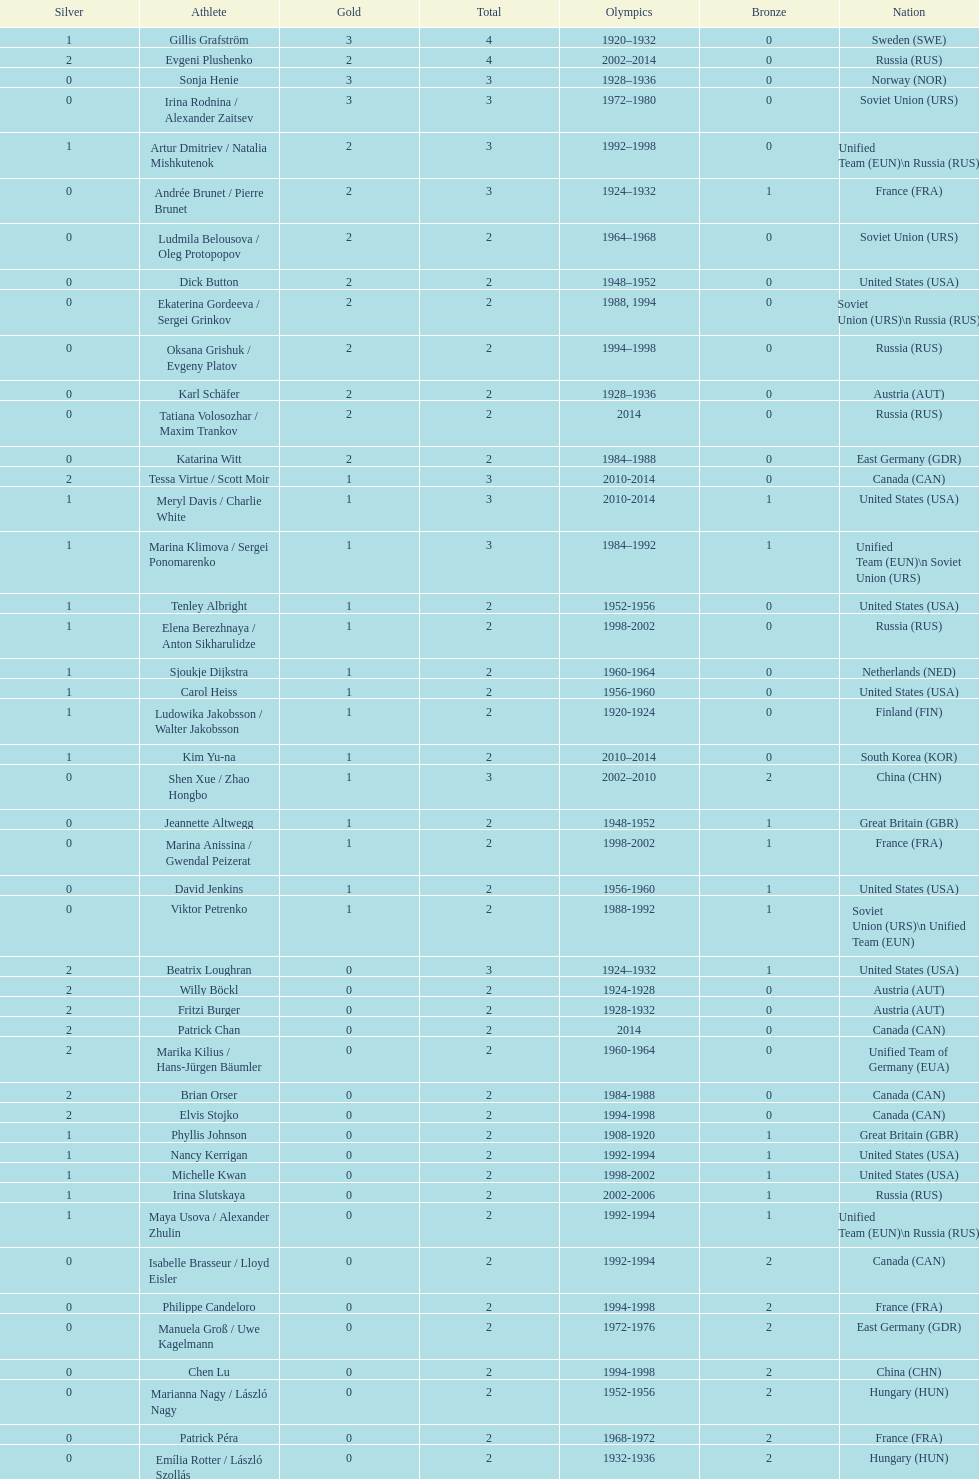How many more silver medals did gillis grafström have compared to sonja henie? 1. Could you parse the entire table as a dict? {'header': ['Silver', 'Athlete', 'Gold', 'Total', 'Olympics', 'Bronze', 'Nation'], 'rows': [['1', 'Gillis Grafström', '3', '4', '1920–1932', '0', 'Sweden\xa0(SWE)'], ['2', 'Evgeni Plushenko', '2', '4', '2002–2014', '0', 'Russia\xa0(RUS)'], ['0', 'Sonja Henie', '3', '3', '1928–1936', '0', 'Norway\xa0(NOR)'], ['0', 'Irina Rodnina / Alexander Zaitsev', '3', '3', '1972–1980', '0', 'Soviet Union\xa0(URS)'], ['1', 'Artur Dmitriev / Natalia Mishkutenok', '2', '3', '1992–1998', '0', 'Unified Team\xa0(EUN)\\n\xa0Russia\xa0(RUS)'], ['0', 'Andrée Brunet / Pierre Brunet', '2', '3', '1924–1932', '1', 'France\xa0(FRA)'], ['0', 'Ludmila Belousova / Oleg Protopopov', '2', '2', '1964–1968', '0', 'Soviet Union\xa0(URS)'], ['0', 'Dick Button', '2', '2', '1948–1952', '0', 'United States\xa0(USA)'], ['0', 'Ekaterina Gordeeva / Sergei Grinkov', '2', '2', '1988, 1994', '0', 'Soviet Union\xa0(URS)\\n\xa0Russia\xa0(RUS)'], ['0', 'Oksana Grishuk / Evgeny Platov', '2', '2', '1994–1998', '0', 'Russia\xa0(RUS)'], ['0', 'Karl Schäfer', '2', '2', '1928–1936', '0', 'Austria\xa0(AUT)'], ['0', 'Tatiana Volosozhar / Maxim Trankov', '2', '2', '2014', '0', 'Russia\xa0(RUS)'], ['0', 'Katarina Witt', '2', '2', '1984–1988', '0', 'East Germany\xa0(GDR)'], ['2', 'Tessa Virtue / Scott Moir', '1', '3', '2010-2014', '0', 'Canada\xa0(CAN)'], ['1', 'Meryl Davis / Charlie White', '1', '3', '2010-2014', '1', 'United States\xa0(USA)'], ['1', 'Marina Klimova / Sergei Ponomarenko', '1', '3', '1984–1992', '1', 'Unified Team\xa0(EUN)\\n\xa0Soviet Union\xa0(URS)'], ['1', 'Tenley Albright', '1', '2', '1952-1956', '0', 'United States\xa0(USA)'], ['1', 'Elena Berezhnaya / Anton Sikharulidze', '1', '2', '1998-2002', '0', 'Russia\xa0(RUS)'], ['1', 'Sjoukje Dijkstra', '1', '2', '1960-1964', '0', 'Netherlands\xa0(NED)'], ['1', 'Carol Heiss', '1', '2', '1956-1960', '0', 'United States\xa0(USA)'], ['1', 'Ludowika Jakobsson / Walter Jakobsson', '1', '2', '1920-1924', '0', 'Finland\xa0(FIN)'], ['1', 'Kim Yu-na', '1', '2', '2010–2014', '0', 'South Korea\xa0(KOR)'], ['0', 'Shen Xue / Zhao Hongbo', '1', '3', '2002–2010', '2', 'China\xa0(CHN)'], ['0', 'Jeannette Altwegg', '1', '2', '1948-1952', '1', 'Great Britain\xa0(GBR)'], ['0', 'Marina Anissina / Gwendal Peizerat', '1', '2', '1998-2002', '1', 'France\xa0(FRA)'], ['0', 'David Jenkins', '1', '2', '1956-1960', '1', 'United States\xa0(USA)'], ['0', 'Viktor Petrenko', '1', '2', '1988-1992', '1', 'Soviet Union\xa0(URS)\\n\xa0Unified Team\xa0(EUN)'], ['2', 'Beatrix Loughran', '0', '3', '1924–1932', '1', 'United States\xa0(USA)'], ['2', 'Willy Böckl', '0', '2', '1924-1928', '0', 'Austria\xa0(AUT)'], ['2', 'Fritzi Burger', '0', '2', '1928-1932', '0', 'Austria\xa0(AUT)'], ['2', 'Patrick Chan', '0', '2', '2014', '0', 'Canada\xa0(CAN)'], ['2', 'Marika Kilius / Hans-Jürgen Bäumler', '0', '2', '1960-1964', '0', 'Unified Team of Germany\xa0(EUA)'], ['2', 'Brian Orser', '0', '2', '1984-1988', '0', 'Canada\xa0(CAN)'], ['2', 'Elvis Stojko', '0', '2', '1994-1998', '0', 'Canada\xa0(CAN)'], ['1', 'Phyllis Johnson', '0', '2', '1908-1920', '1', 'Great Britain\xa0(GBR)'], ['1', 'Nancy Kerrigan', '0', '2', '1992-1994', '1', 'United States\xa0(USA)'], ['1', 'Michelle Kwan', '0', '2', '1998-2002', '1', 'United States\xa0(USA)'], ['1', 'Irina Slutskaya', '0', '2', '2002-2006', '1', 'Russia\xa0(RUS)'], ['1', 'Maya Usova / Alexander Zhulin', '0', '2', '1992-1994', '1', 'Unified Team\xa0(EUN)\\n\xa0Russia\xa0(RUS)'], ['0', 'Isabelle Brasseur / Lloyd Eisler', '0', '2', '1992-1994', '2', 'Canada\xa0(CAN)'], ['0', 'Philippe Candeloro', '0', '2', '1994-1998', '2', 'France\xa0(FRA)'], ['0', 'Manuela Groß / Uwe Kagelmann', '0', '2', '1972-1976', '2', 'East Germany\xa0(GDR)'], ['0', 'Chen Lu', '0', '2', '1994-1998', '2', 'China\xa0(CHN)'], ['0', 'Marianna Nagy / László Nagy', '0', '2', '1952-1956', '2', 'Hungary\xa0(HUN)'], ['0', 'Patrick Péra', '0', '2', '1968-1972', '2', 'France\xa0(FRA)'], ['0', 'Emília Rotter / László Szollás', '0', '2', '1932-1936', '2', 'Hungary\xa0(HUN)'], ['0', 'Aliona Savchenko / Robin Szolkowy', '0', '2', '2010-2014', '2', 'Germany\xa0(GER)']]} 